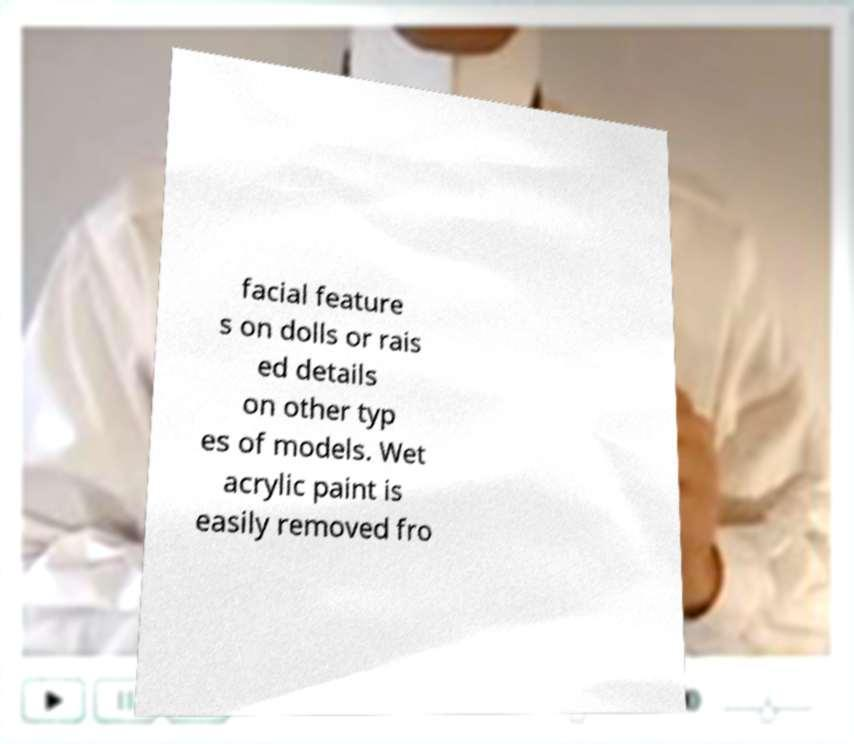There's text embedded in this image that I need extracted. Can you transcribe it verbatim? facial feature s on dolls or rais ed details on other typ es of models. Wet acrylic paint is easily removed fro 